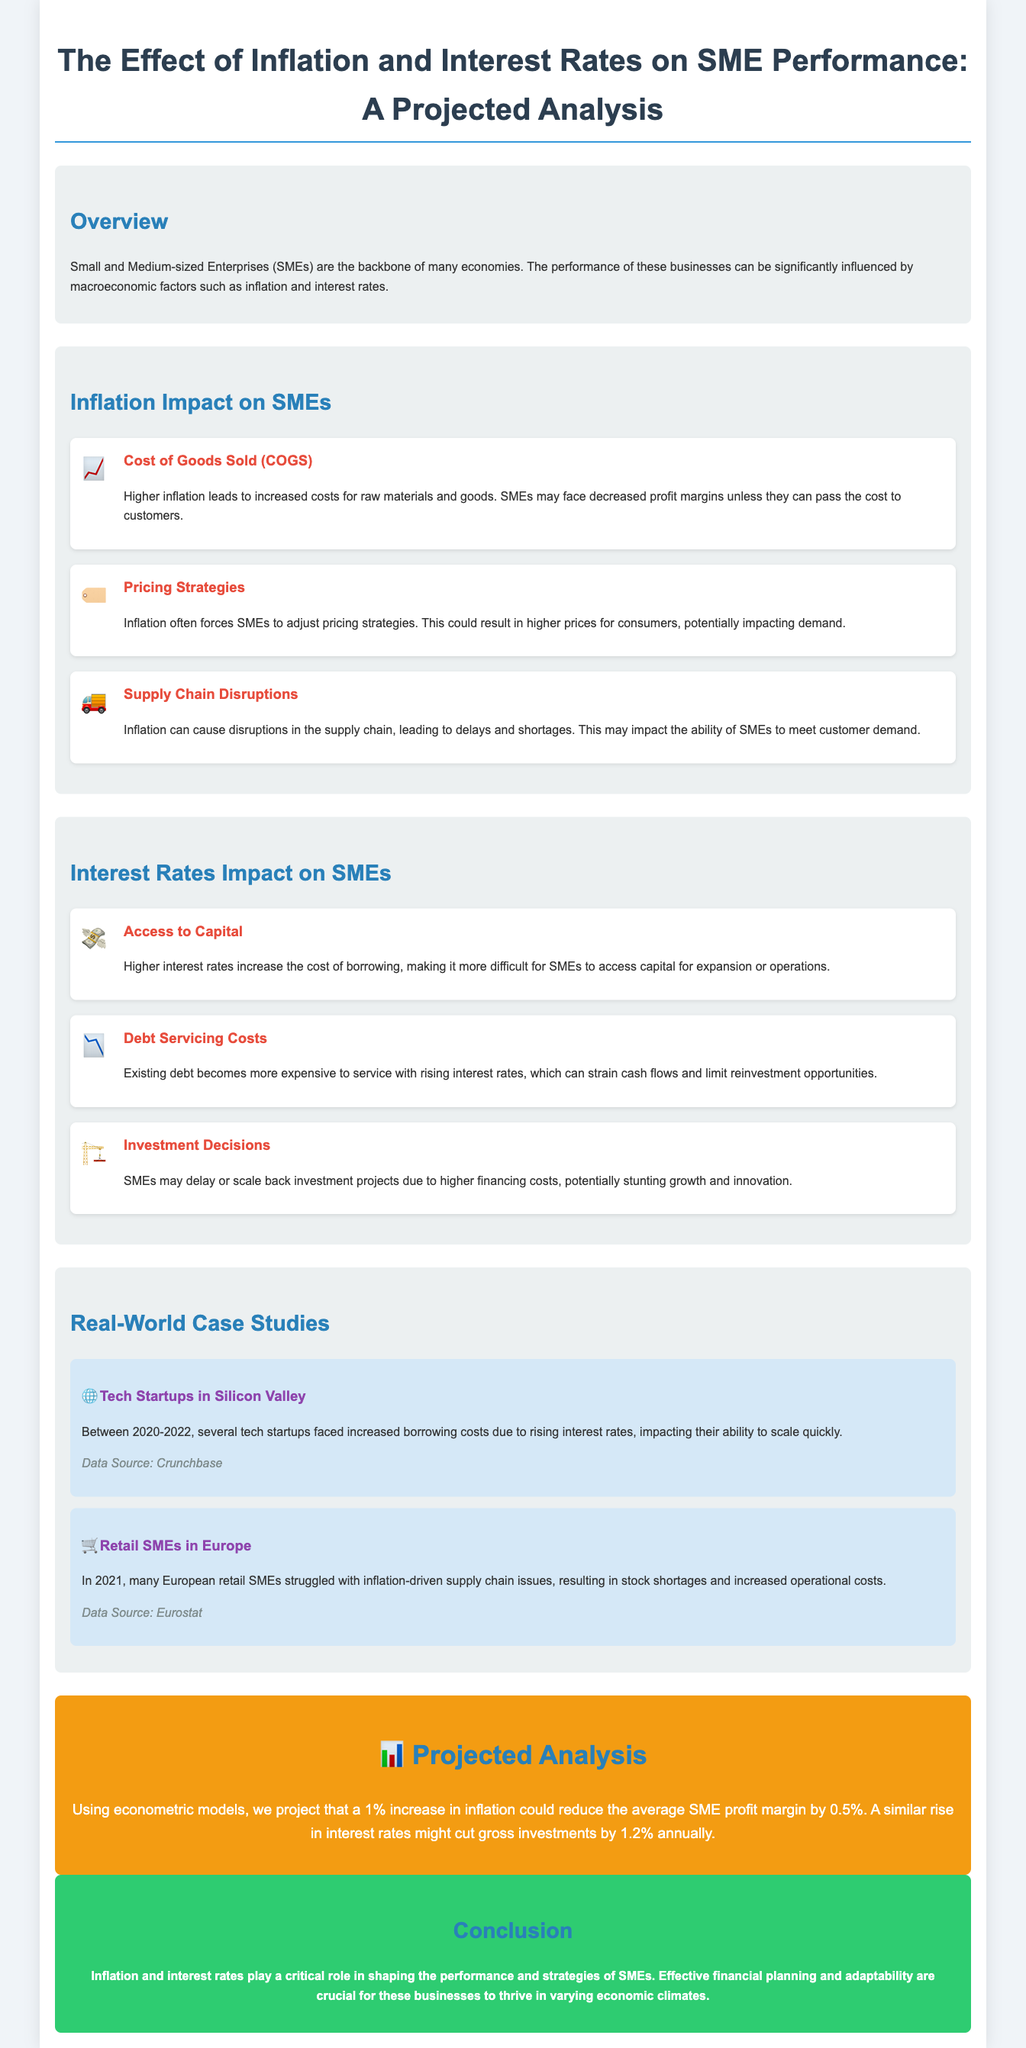What is the main focus of the document? The main focus is on the impact of inflation and interest rates on the performance of SMEs.
Answer: Impact of inflation and interest rates on SME performance What is the projected reduction in SME profit margin with a 1% increase in inflation? The projected reduction in SME profit margin with a 1% increase in inflation is specified in the document.
Answer: 0.5% Which specific costs rise for SMEs due to higher interest rates? The document mentions that the cost of borrowing increases due to higher interest rates.
Answer: Cost of borrowing What might SMEs face in relation to their pricing strategies because of inflation? The document suggests that SMEs may need to adjust their pricing strategies due to inflation.
Answer: Adjust pricing strategies What sector is highlighted in one of the case studies experiencing inflation-driven issues? The document contains a case study focused on the retail sector in Europe facing inflation-driven issues.
Answer: Retail How much might gross investments decline annually with a rise in interest rates? The document provides a specific figure projecting a decline in gross investments due to a rise in interest rates.
Answer: 1.2% What is an example provided in the case studies? The document includes real-world examples to illustrate the effect of inflation and interest rates on SMEs.
Answer: Tech Startups in Silicon Valley What structural element is used to categorize the different impacts of inflation and interest rates? The document uses subsections to categorize the impacts of inflation and interest rates on SMEs.
Answer: Subsections 